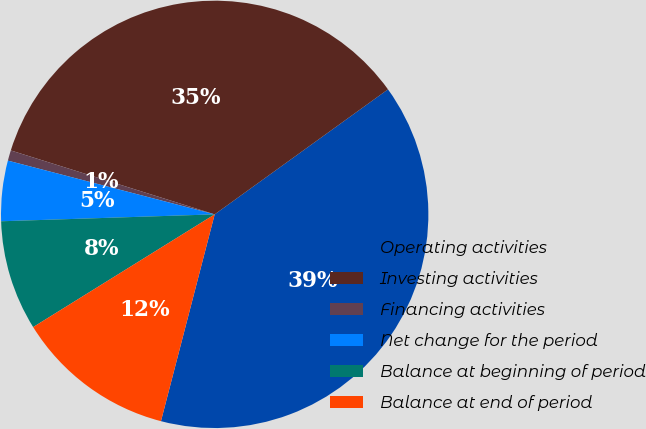Convert chart to OTSL. <chart><loc_0><loc_0><loc_500><loc_500><pie_chart><fcel>Operating activities<fcel>Investing activities<fcel>Financing activities<fcel>Net change for the period<fcel>Balance at beginning of period<fcel>Balance at end of period<nl><fcel>38.99%<fcel>35.22%<fcel>0.79%<fcel>4.56%<fcel>8.33%<fcel>12.11%<nl></chart> 